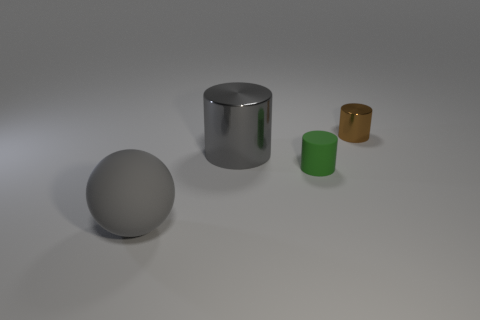What number of other things are there of the same color as the large sphere?
Your answer should be very brief. 1. There is a tiny object on the right side of the tiny object in front of the large gray cylinder; what number of tiny brown cylinders are behind it?
Offer a very short reply. 0. What color is the big shiny object that is the same shape as the small brown object?
Offer a terse response. Gray. The thing that is behind the large object on the right side of the thing that is in front of the green cylinder is what shape?
Offer a terse response. Cylinder. What size is the thing that is behind the tiny matte thing and left of the small green cylinder?
Your answer should be compact. Large. Are there fewer green objects than large red metal cylinders?
Give a very brief answer. No. There is a gray metallic thing that is behind the green rubber object; what is its size?
Offer a very short reply. Large. What shape is the thing that is both behind the small green thing and in front of the brown shiny cylinder?
Your response must be concise. Cylinder. There is a gray metal thing that is the same shape as the tiny brown object; what size is it?
Offer a terse response. Large. What number of yellow things have the same material as the gray sphere?
Your answer should be compact. 0. 